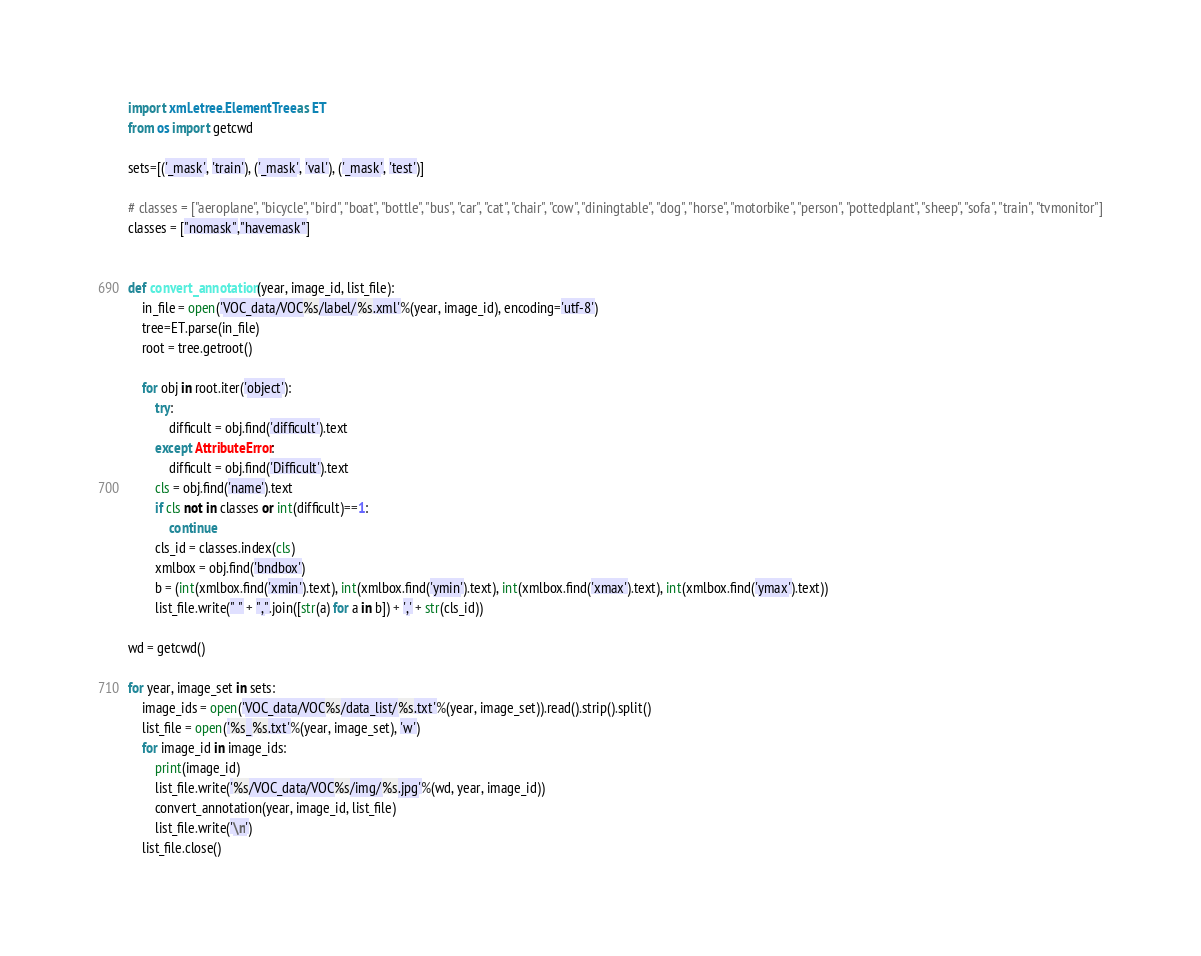<code> <loc_0><loc_0><loc_500><loc_500><_Python_>import xml.etree.ElementTree as ET
from os import getcwd

sets=[('_mask', 'train'), ('_mask', 'val'), ('_mask', 'test')]

# classes = ["aeroplane", "bicycle", "bird", "boat", "bottle", "bus", "car", "cat", "chair", "cow", "diningtable", "dog", "horse", "motorbike", "person", "pottedplant", "sheep", "sofa", "train", "tvmonitor"]
classes = ["nomask","havemask"]


def convert_annotation(year, image_id, list_file):
    in_file = open('VOC_data/VOC%s/label/%s.xml'%(year, image_id), encoding='utf-8')
    tree=ET.parse(in_file)
    root = tree.getroot()

    for obj in root.iter('object'):
        try:
            difficult = obj.find('difficult').text
        except AttributeError:
            difficult = obj.find('Difficult').text
        cls = obj.find('name').text
        if cls not in classes or int(difficult)==1:
            continue
        cls_id = classes.index(cls)
        xmlbox = obj.find('bndbox')
        b = (int(xmlbox.find('xmin').text), int(xmlbox.find('ymin').text), int(xmlbox.find('xmax').text), int(xmlbox.find('ymax').text))
        list_file.write(" " + ",".join([str(a) for a in b]) + ',' + str(cls_id))

wd = getcwd()

for year, image_set in sets:
    image_ids = open('VOC_data/VOC%s/data_list/%s.txt'%(year, image_set)).read().strip().split()
    list_file = open('%s_%s.txt'%(year, image_set), 'w')
    for image_id in image_ids:
        print(image_id)
        list_file.write('%s/VOC_data/VOC%s/img/%s.jpg'%(wd, year, image_id))
        convert_annotation(year, image_id, list_file)
        list_file.write('\n')
    list_file.close()

</code> 